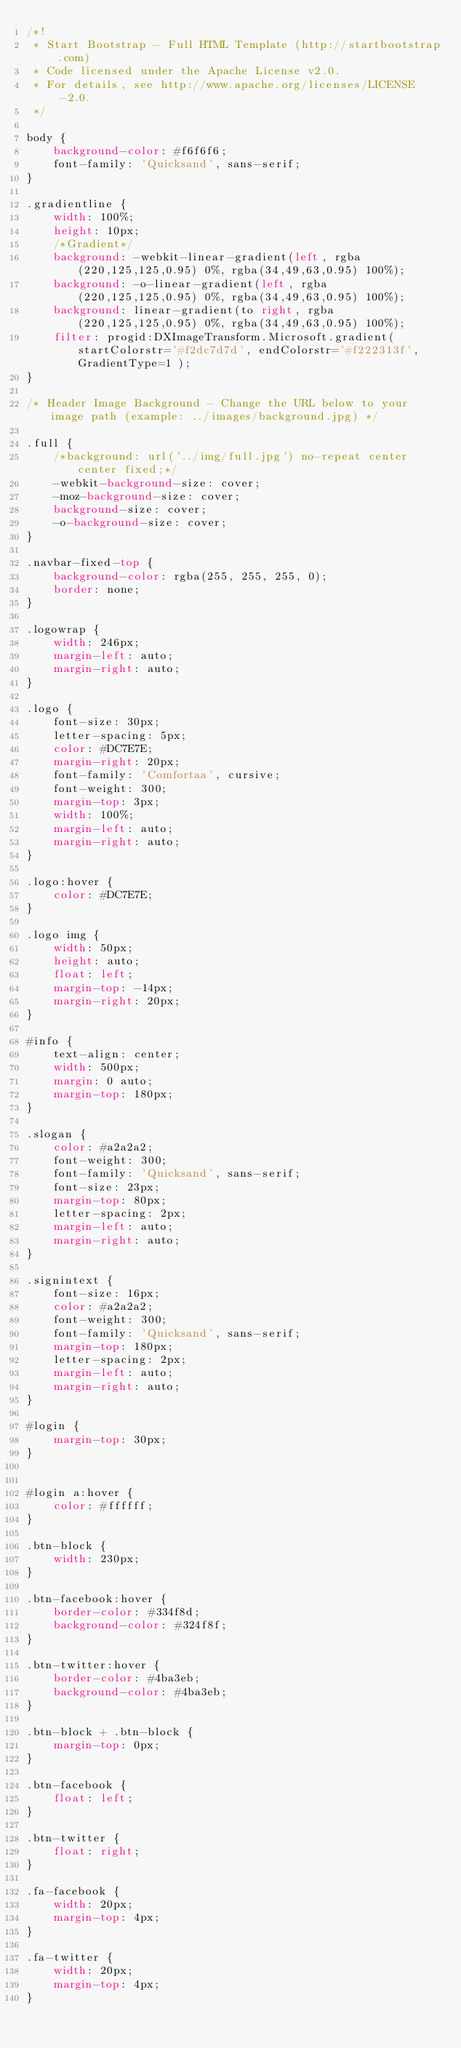Convert code to text. <code><loc_0><loc_0><loc_500><loc_500><_CSS_>/*!
 * Start Bootstrap - Full HTML Template (http://startbootstrap.com)
 * Code licensed under the Apache License v2.0.
 * For details, see http://www.apache.org/licenses/LICENSE-2.0.
 */

body {
    background-color: #f6f6f6;
    font-family: 'Quicksand', sans-serif;
}

.gradientline {
    width: 100%;
    height: 10px;
    /*Gradient*/
    background: -webkit-linear-gradient(left, rgba(220,125,125,0.95) 0%, rgba(34,49,63,0.95) 100%);
    background: -o-linear-gradient(left, rgba(220,125,125,0.95) 0%, rgba(34,49,63,0.95) 100%);
    background: linear-gradient(to right, rgba(220,125,125,0.95) 0%, rgba(34,49,63,0.95) 100%);
    filter: progid:DXImageTransform.Microsoft.gradient( startColorstr='#f2dc7d7d', endColorstr='#f222313f',GradientType=1 );
}

/* Header Image Background - Change the URL below to your image path (example: ../images/background.jpg) */

.full {
    /*background: url('../img/full.jpg') no-repeat center center fixed;*/
    -webkit-background-size: cover;
    -moz-background-size: cover;
    background-size: cover;
    -o-background-size: cover;
}

.navbar-fixed-top {
    background-color: rgba(255, 255, 255, 0);
    border: none;
}

.logowrap {
    width: 246px;
    margin-left: auto;
    margin-right: auto;
}

.logo {
    font-size: 30px;
	letter-spacing: 5px;
	color: #DC7E7E;
	margin-right: 20px;
	font-family: 'Comfortaa', cursive;
	font-weight: 300;
	margin-top: 3px;
    width: 100%;
    margin-left: auto;
    margin-right: auto;
}

.logo:hover {
	color: #DC7E7E;
}

.logo img {
	width: 50px;
	height: auto;
	float: left;
	margin-top: -14px;
	margin-right: 20px;
}

#info {
    text-align: center;
    width: 500px;
    margin: 0 auto;
    margin-top: 180px;
}

.slogan {
    color: #a2a2a2;
    font-weight: 300;
    font-family: 'Quicksand', sans-serif;
    font-size: 23px;
    margin-top: 80px;
    letter-spacing: 2px;
    margin-left: auto;
    margin-right: auto;
}

.signintext {
    font-size: 16px;
    color: #a2a2a2;
    font-weight: 300;
    font-family: 'Quicksand', sans-serif;
    margin-top: 180px;
    letter-spacing: 2px;
    margin-left: auto;
    margin-right: auto;
}

#login {
    margin-top: 30px;
}


#login a:hover {
    color: #ffffff;
}

.btn-block {
    width: 230px;
}

.btn-facebook:hover {
    border-color: #334f8d;
    background-color: #324f8f;
}

.btn-twitter:hover {
    border-color: #4ba3eb;
    background-color: #4ba3eb;
}

.btn-block + .btn-block {
    margin-top: 0px;
}

.btn-facebook {
    float: left;
}

.btn-twitter {
    float: right;
}

.fa-facebook {
    width: 20px;
    margin-top: 4px;
}

.fa-twitter {
    width: 20px;
    margin-top: 4px;
}
</code> 